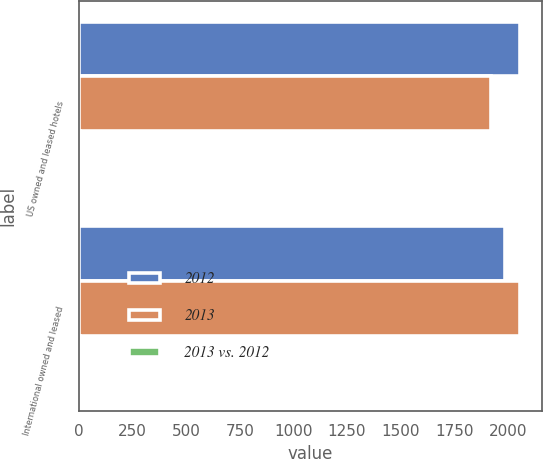Convert chart to OTSL. <chart><loc_0><loc_0><loc_500><loc_500><stacked_bar_chart><ecel><fcel>US owned and leased hotels<fcel>International owned and leased<nl><fcel>2012<fcel>2058<fcel>1988<nl><fcel>2013<fcel>1922<fcel>2057<nl><fcel>2013 vs. 2012<fcel>7.1<fcel>3.4<nl></chart> 